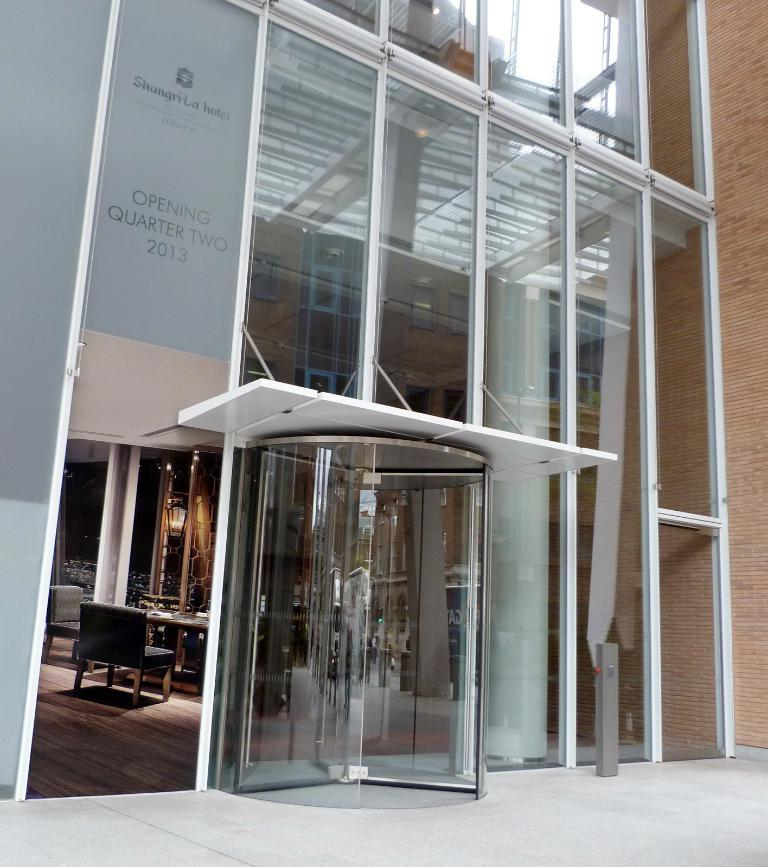What type of structure is visible in the image? There is a building in the image. What feature can be observed on the building? The building has glass elements. What furniture is present inside the building? There is a table and chairs inside the building. How many nuts are on the tray in the image? There is no tray or nuts present in the image. What type of frogs can be seen inside the building? There are no frogs present in the image. 